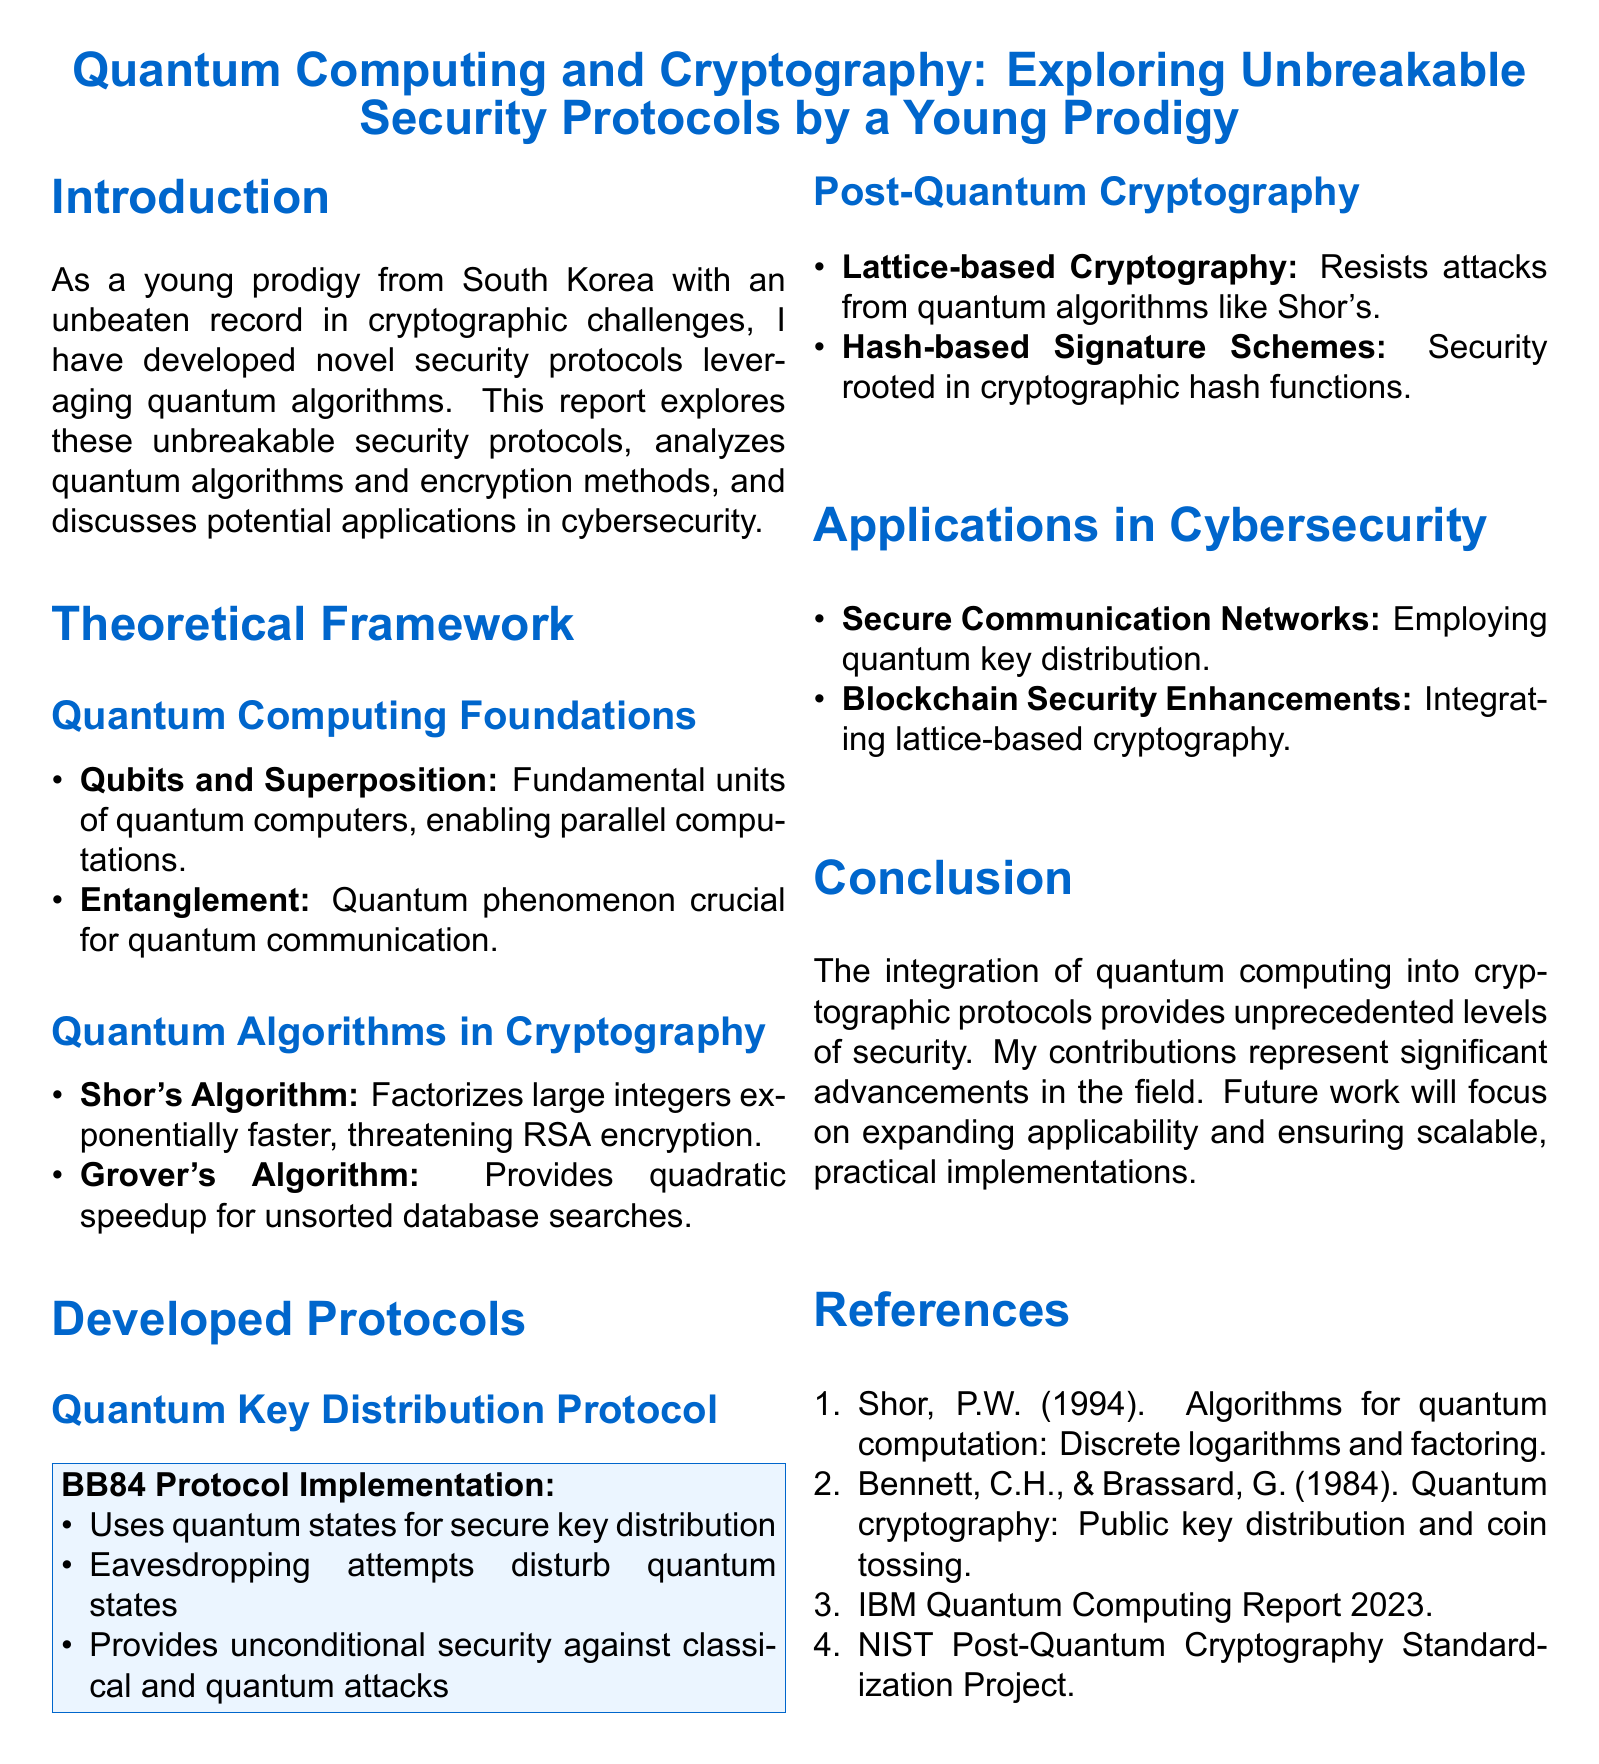What is the name of the young prodigy? The document refers to a young prodigy from South Korea, but does not provide a specific name.
Answer: South Korea What year was Shor's Algorithm introduced? The reference indicates that Shor's Algorithm was presented in 1994.
Answer: 1994 What is the primary focus of the BB84 Protocol? The document states that the BB84 Protocol uses quantum states for secure key distribution.
Answer: Secure key distribution What type of cryptography resists attacks from quantum algorithms like Shor's? The report mentions lattice-based cryptography as resistant to quantum algorithm attacks.
Answer: Lattice-based Cryptography Which quantum phenomenon is crucial for quantum communication? The document highlights entanglement as a key quantum phenomenon for communication.
Answer: Entanglement What advantage does Grover's Algorithm provide? The document states Grover's Algorithm provides quadratic speedup for unsorted database searches.
Answer: Quadratic speedup What is the conclusion about the integration of quantum computing into cryptographic protocols? The report concludes that the integration provides unprecedented levels of security.
Answer: Unprecedented levels of security What type of networks employ quantum key distribution? The document refers to secure communication networks as employing quantum key distribution.
Answer: Secure Communication Networks What are the two areas of focus for future work mentioned in the conclusion? The document notes that future work will focus on expanding applicability and ensuring scalable, practical implementations.
Answer: Expanding applicability and ensuring scalable, practical implementations 